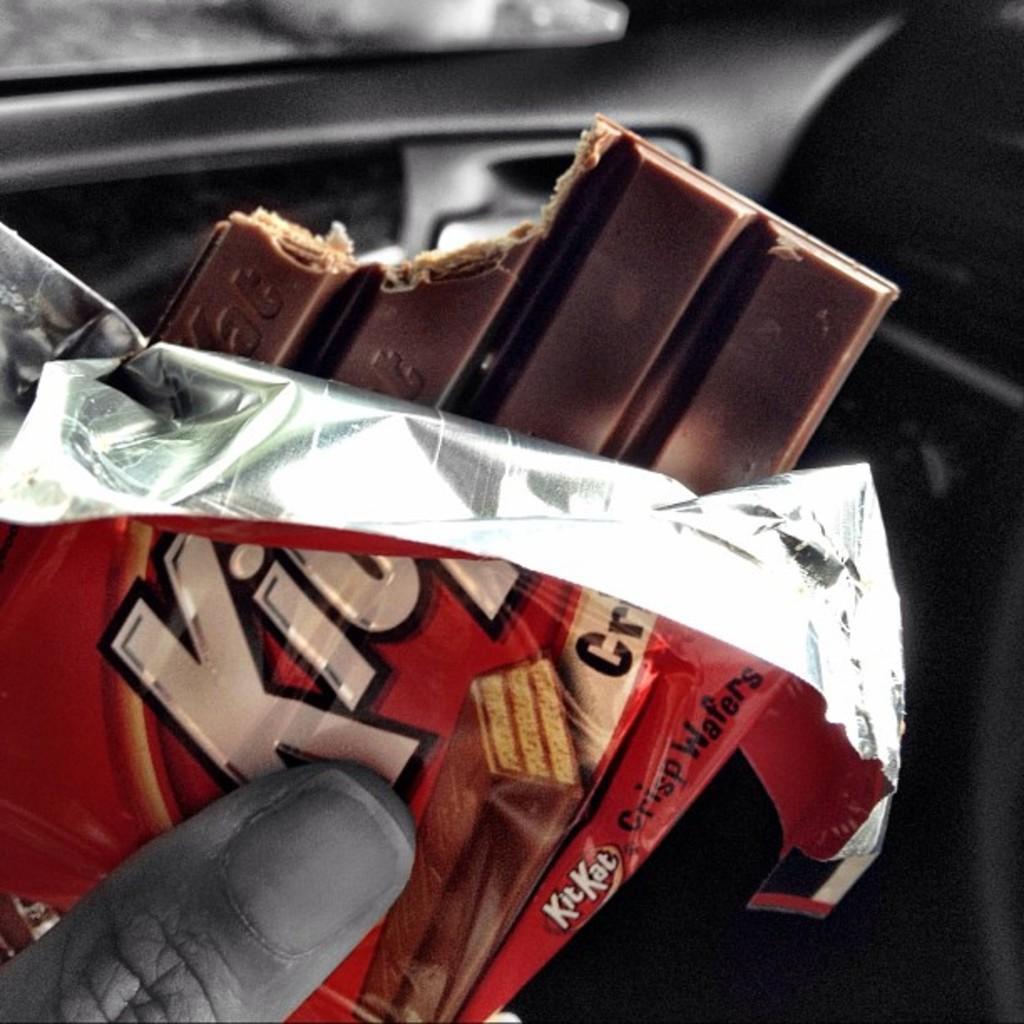Please provide a concise description of this image. In this picture we can see a person is holding kitkat chocolate. 